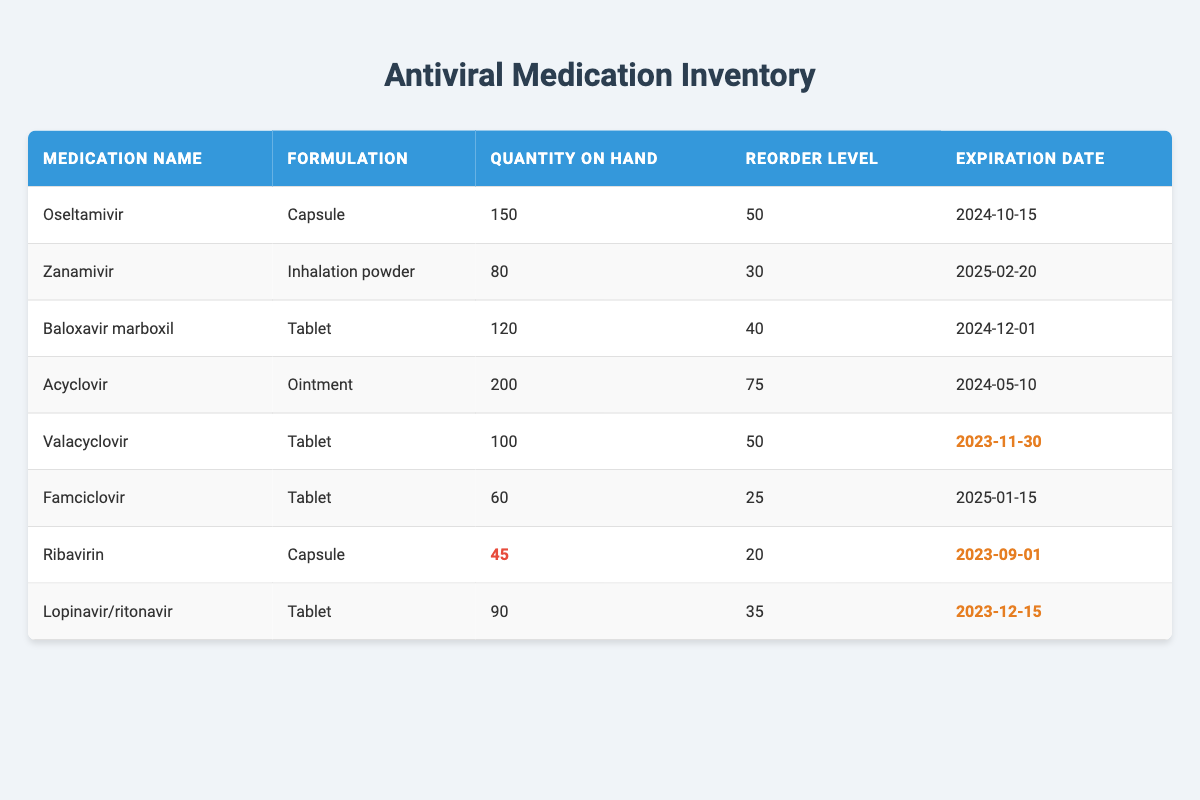What is the quantity on hand for Oseltamivir? The quantity on hand is directly listed in the table under the "Quantity on Hand" column for Oseltamivir. It shows 150.
Answer: 150 How many antiviral medications have a reorder level of 50 or lower? We look for medications that have "Reorder Level" values of 50 or lower. From the table, Valacyclovir (50), Famciclovir (25), Ribavirin (20), and Lopinavir/ritonavir (35) meet this criteria. That's a total of four medications.
Answer: 4 Is Acyclovir expiring before Valacyclovir? The expiration date for Acyclovir is 2024-05-10, while for Valacyclovir it is 2023-11-30. Since 2024-05-10 is after 2023-11-30, Acyclovir is not expiring before Valacyclovir.
Answer: No What is the total quantity on hand for all medications? The total quantity is calculated by summing the "Quantity on Hand" values across all medications: 150 + 80 + 120 + 200 + 100 + 60 + 45 + 90 = 845. This total is the sum of the individual quantities in the table.
Answer: 845 Which medication has the earliest expiration date? By comparing the expiration dates listed for each medication, Ribavirin with an expiration date of 2023-09-01 is the earliest. The process involved scanning each expiration date in the "Expiration Date" column to determine which is the smallest.
Answer: Ribavirin How many medications are below their reorder level? Ribavirin (45 with reorder level 20), Famciclovir (60 with reorder level 25), and Lopinavir/ritonavir (90 with reorder level 35) are all below their reorder levels. Ribavirin is the only one significantly below, having only 45. To find this, we compare each medication's "Quantity on Hand" to its "Reorder Level".
Answer: 1 Is there any medication that has both low stock and is expiring soon? Ribavirin has a "Quantity on Hand" of 45 (marked as low stock) and an expiration date of 2023-09-01 (which is soon). By examining the "Low Stock" and "Expiring Soon" criteria in the table, we see that Ribavirin meets both.
Answer: Yes 